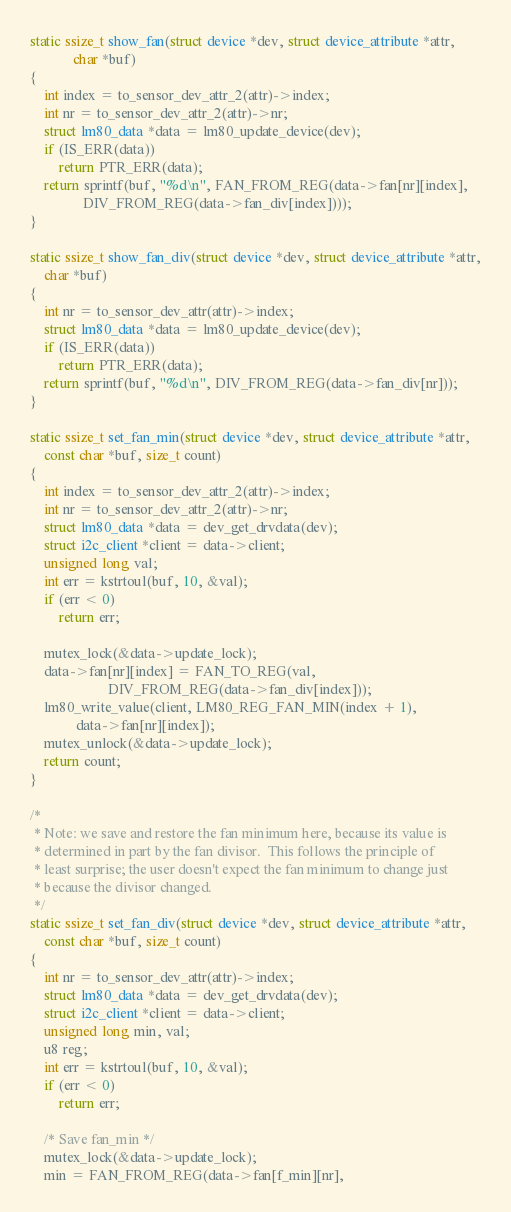<code> <loc_0><loc_0><loc_500><loc_500><_C_>
static ssize_t show_fan(struct device *dev, struct device_attribute *attr,
			char *buf)
{
	int index = to_sensor_dev_attr_2(attr)->index;
	int nr = to_sensor_dev_attr_2(attr)->nr;
	struct lm80_data *data = lm80_update_device(dev);
	if (IS_ERR(data))
		return PTR_ERR(data);
	return sprintf(buf, "%d\n", FAN_FROM_REG(data->fan[nr][index],
		       DIV_FROM_REG(data->fan_div[index])));
}

static ssize_t show_fan_div(struct device *dev, struct device_attribute *attr,
	char *buf)
{
	int nr = to_sensor_dev_attr(attr)->index;
	struct lm80_data *data = lm80_update_device(dev);
	if (IS_ERR(data))
		return PTR_ERR(data);
	return sprintf(buf, "%d\n", DIV_FROM_REG(data->fan_div[nr]));
}

static ssize_t set_fan_min(struct device *dev, struct device_attribute *attr,
	const char *buf, size_t count)
{
	int index = to_sensor_dev_attr_2(attr)->index;
	int nr = to_sensor_dev_attr_2(attr)->nr;
	struct lm80_data *data = dev_get_drvdata(dev);
	struct i2c_client *client = data->client;
	unsigned long val;
	int err = kstrtoul(buf, 10, &val);
	if (err < 0)
		return err;

	mutex_lock(&data->update_lock);
	data->fan[nr][index] = FAN_TO_REG(val,
					  DIV_FROM_REG(data->fan_div[index]));
	lm80_write_value(client, LM80_REG_FAN_MIN(index + 1),
			 data->fan[nr][index]);
	mutex_unlock(&data->update_lock);
	return count;
}

/*
 * Note: we save and restore the fan minimum here, because its value is
 * determined in part by the fan divisor.  This follows the principle of
 * least surprise; the user doesn't expect the fan minimum to change just
 * because the divisor changed.
 */
static ssize_t set_fan_div(struct device *dev, struct device_attribute *attr,
	const char *buf, size_t count)
{
	int nr = to_sensor_dev_attr(attr)->index;
	struct lm80_data *data = dev_get_drvdata(dev);
	struct i2c_client *client = data->client;
	unsigned long min, val;
	u8 reg;
	int err = kstrtoul(buf, 10, &val);
	if (err < 0)
		return err;

	/* Save fan_min */
	mutex_lock(&data->update_lock);
	min = FAN_FROM_REG(data->fan[f_min][nr],</code> 